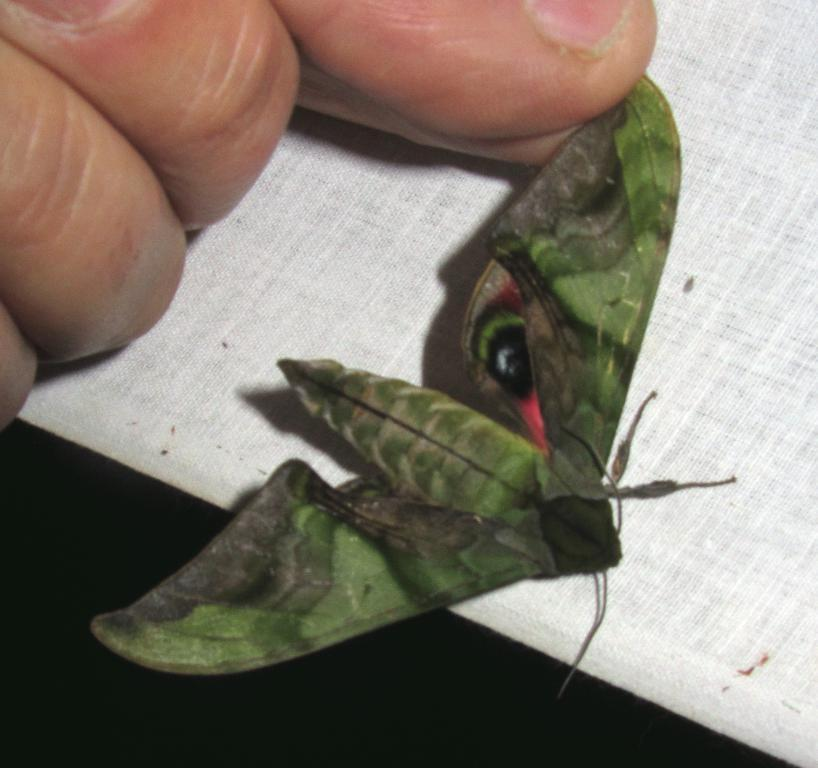Who or what is the main subject in the image? There is a person in the image. What is the person holding in the image? The person is holding a green color butterfly. What can be seen at the bottom of the image? There is a white color cloth at the bottom of the image. What type of insurance policy is the person discussing in the image? There is no indication in the image that the person is discussing any insurance policy. 